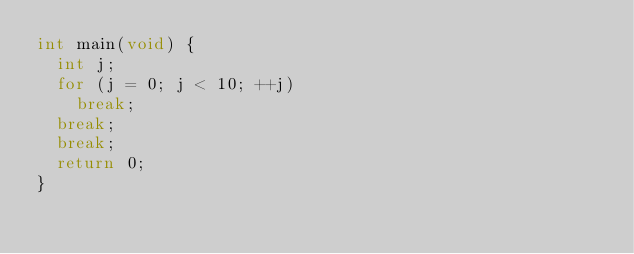Convert code to text. <code><loc_0><loc_0><loc_500><loc_500><_C_>int main(void) {
  int j;
  for (j = 0; j < 10; ++j)
    break;
  break;
  break;
  return 0;
}</code> 